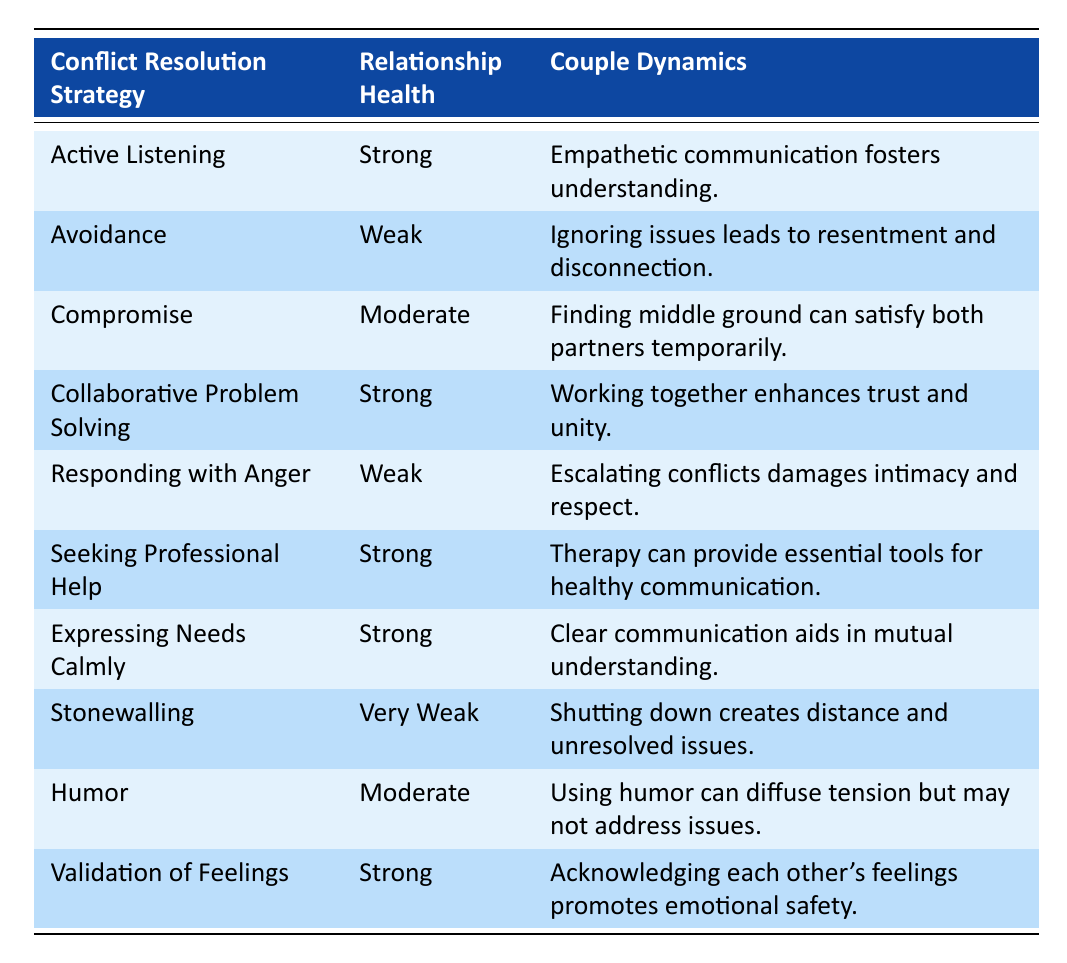What is the relationship health associated with the strategy of Active Listening? According to the table, the strategy of Active Listening corresponds to a relationship health classification of Strong.
Answer: Strong What couple dynamics are linked to Seeking Professional Help? The table shows that the couple dynamics associated with Seeking Professional Help is that therapy can provide essential tools for healthy communication.
Answer: Therapy can provide essential tools for healthy communication How many conflict resolution strategies are categorized as Strong? By checking the table, we see that there are four strategies: Active Listening, Collaborative Problem Solving, Seeking Professional Help, and Expressing Needs Calmly. Therefore, there are four strategies with Strong relationship health.
Answer: 4 What is the difference in relationship health between Avoidance and Stonewalling? The relationship health for Avoidance is Weak, and for Stonewalling, it is Very Weak. The difference in classification is one level, as Weak is higher than Very Weak.
Answer: 1 level Is it true that using Humor leads to Strong relationship health? Referring to the table, Humor is categorized as having Moderate relationship health, so the statement is false.
Answer: False What is the overall trend in relationship health when using Active Listening versus Responding with Anger? Looking at the table, Active Listening results in Strong relationship health, while Responding with Anger results in Weak relationship health. The trend indicates that Active Listening positively impacts relationship health, whereas Responding with Anger negatively affects it.
Answer: Active Listening is Strong; Responding with Anger is Weak Which conflict resolution strategy has the weakest relationship health, and what does it suggest about couple dynamics? Stonewalling is listed as having Very Weak relationship health. This suggests that shutting down creates distance and unresolved issues within the relationship.
Answer: Stonewalling; it creates distance and unresolved issues If a couple uses the strategy of Validation of Feelings, what type of couple dynamics can they expect? The table indicates that Validation of Feelings promotes emotional safety, suggesting that acknowledging each other's feelings can improve their relationship dynamics.
Answer: Promotes emotional safety 